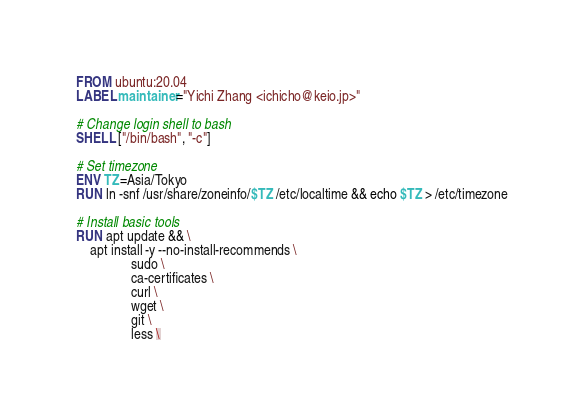Convert code to text. <code><loc_0><loc_0><loc_500><loc_500><_Dockerfile_>FROM ubuntu:20.04
LABEL maintainer="Yichi Zhang <ichicho@keio.jp>"

# Change login shell to bash
SHELL ["/bin/bash", "-c"]

# Set timezone
ENV TZ=Asia/Tokyo
RUN ln -snf /usr/share/zoneinfo/$TZ /etc/localtime && echo $TZ > /etc/timezone

# Install basic tools
RUN apt update && \
    apt install -y --no-install-recommends \
                sudo \
                ca-certificates \
                curl \
                wget \
                git \
                less \</code> 